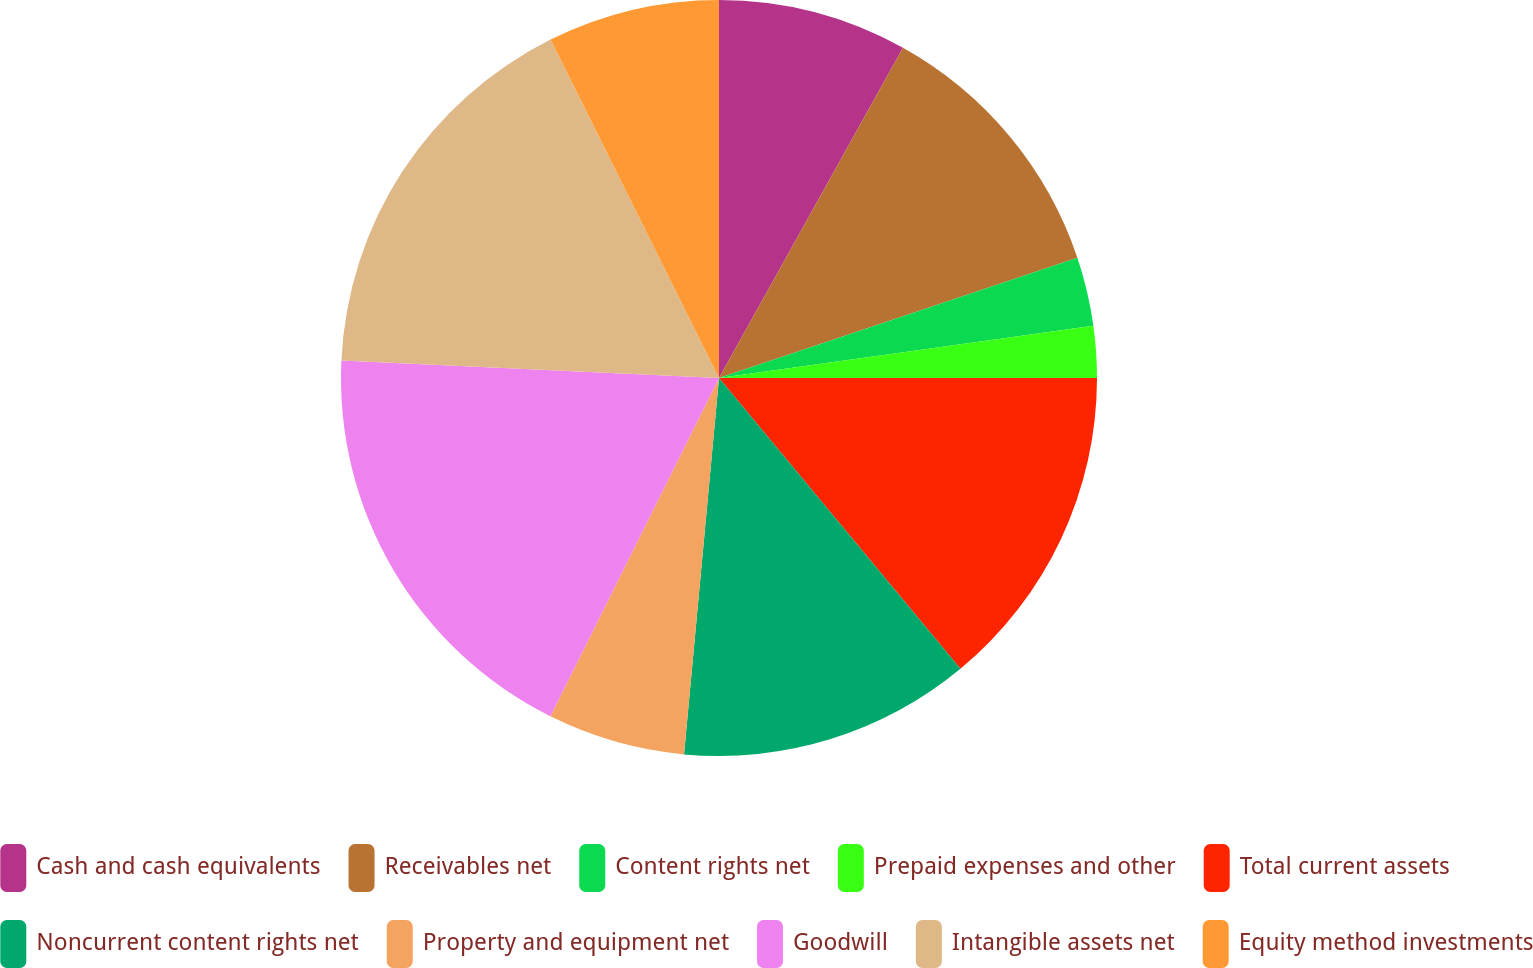<chart> <loc_0><loc_0><loc_500><loc_500><pie_chart><fcel>Cash and cash equivalents<fcel>Receivables net<fcel>Content rights net<fcel>Prepaid expenses and other<fcel>Total current assets<fcel>Noncurrent content rights net<fcel>Property and equipment net<fcel>Goodwill<fcel>Intangible assets net<fcel>Equity method investments<nl><fcel>8.09%<fcel>11.76%<fcel>2.94%<fcel>2.21%<fcel>13.97%<fcel>12.5%<fcel>5.88%<fcel>18.38%<fcel>16.91%<fcel>7.35%<nl></chart> 